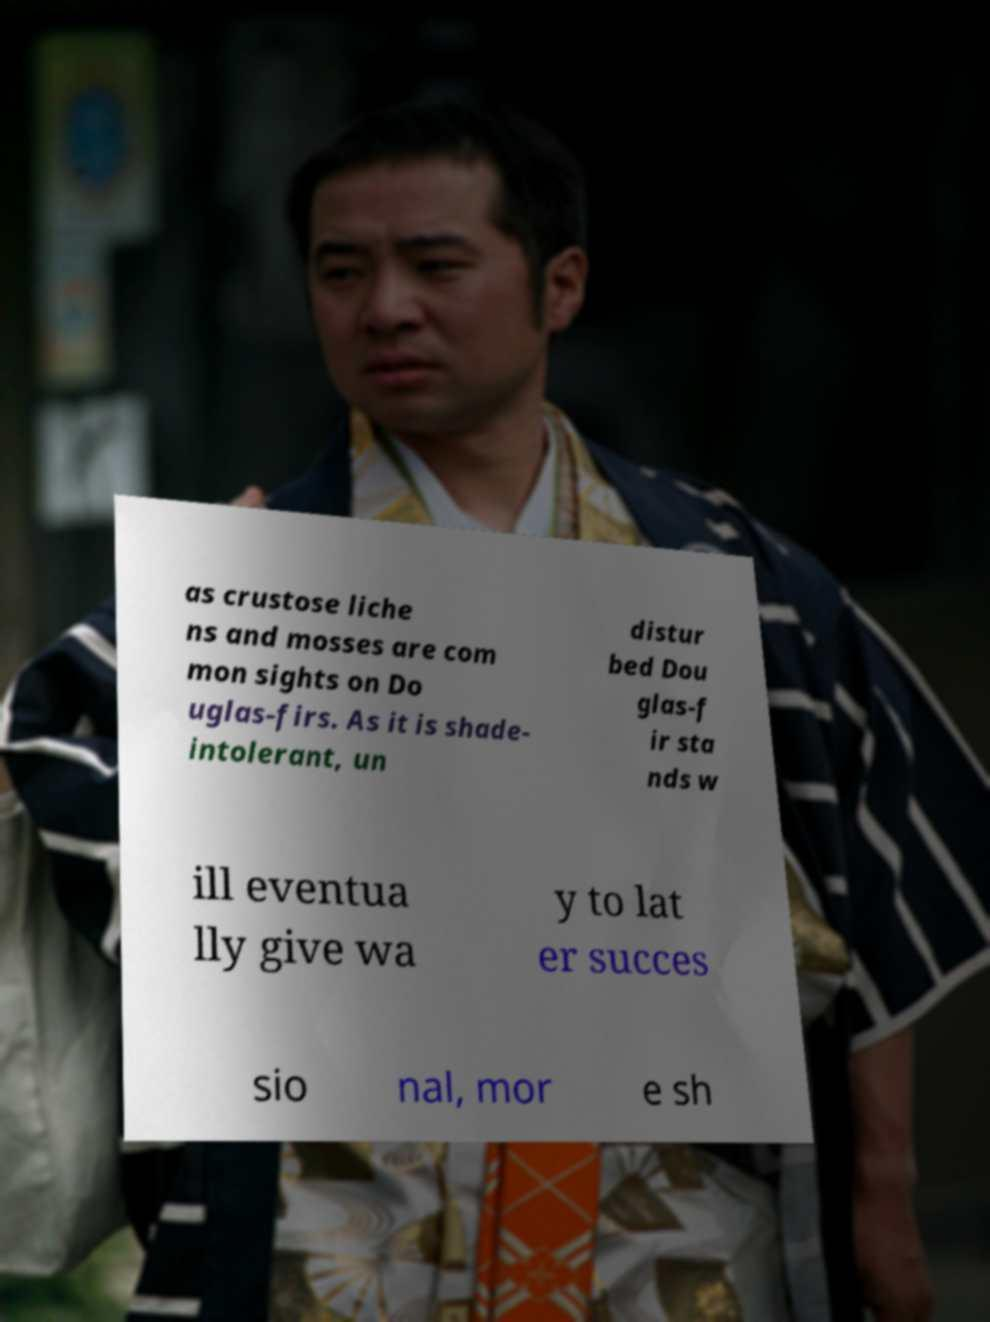What messages or text are displayed in this image? I need them in a readable, typed format. as crustose liche ns and mosses are com mon sights on Do uglas-firs. As it is shade- intolerant, un distur bed Dou glas-f ir sta nds w ill eventua lly give wa y to lat er succes sio nal, mor e sh 